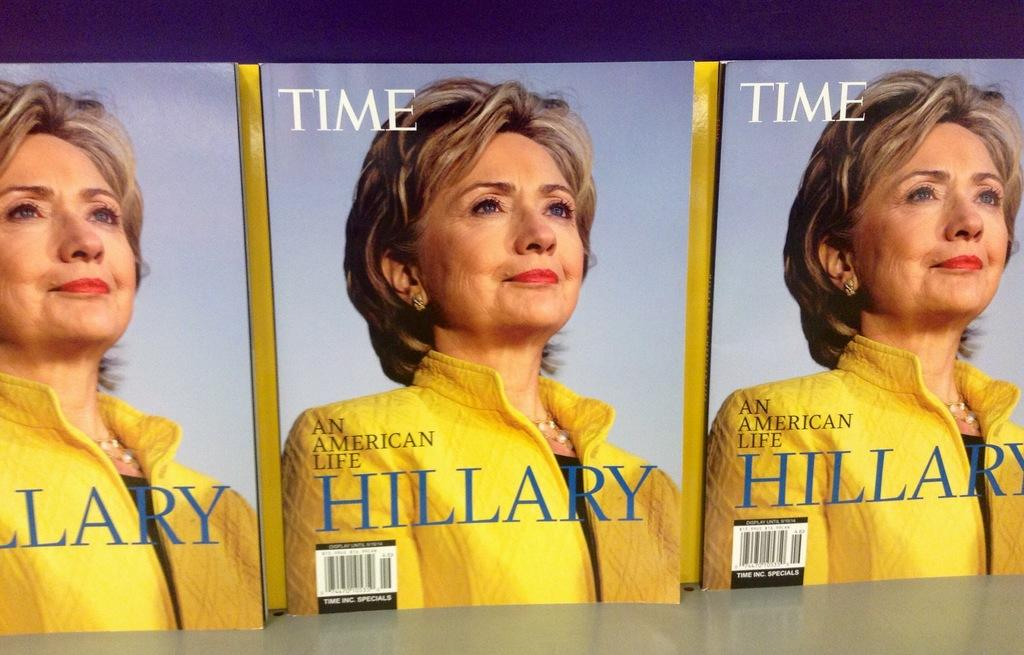How many magazines are visible in the image? There are three magazines in the image. What is featured on the cover of the magazines? There is a picture of a woman on the magazines. What else can be seen on the magazines besides the picture? There is text on the magazines. What type of camera is the woman using in the image? There is no camera or woman using a camera present in the image; it features three magazines with a picture of a woman on them. What sound does the whistle make in the image? There is no whistle present in the image. 